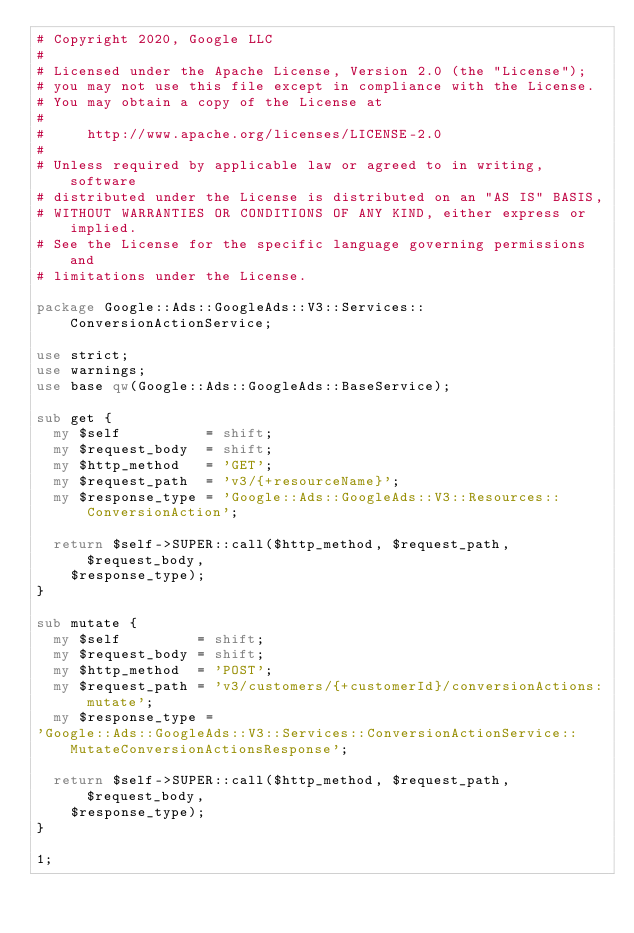Convert code to text. <code><loc_0><loc_0><loc_500><loc_500><_Perl_># Copyright 2020, Google LLC
#
# Licensed under the Apache License, Version 2.0 (the "License");
# you may not use this file except in compliance with the License.
# You may obtain a copy of the License at
#
#     http://www.apache.org/licenses/LICENSE-2.0
#
# Unless required by applicable law or agreed to in writing, software
# distributed under the License is distributed on an "AS IS" BASIS,
# WITHOUT WARRANTIES OR CONDITIONS OF ANY KIND, either express or implied.
# See the License for the specific language governing permissions and
# limitations under the License.

package Google::Ads::GoogleAds::V3::Services::ConversionActionService;

use strict;
use warnings;
use base qw(Google::Ads::GoogleAds::BaseService);

sub get {
  my $self          = shift;
  my $request_body  = shift;
  my $http_method   = 'GET';
  my $request_path  = 'v3/{+resourceName}';
  my $response_type = 'Google::Ads::GoogleAds::V3::Resources::ConversionAction';

  return $self->SUPER::call($http_method, $request_path, $request_body,
    $response_type);
}

sub mutate {
  my $self         = shift;
  my $request_body = shift;
  my $http_method  = 'POST';
  my $request_path = 'v3/customers/{+customerId}/conversionActions:mutate';
  my $response_type =
'Google::Ads::GoogleAds::V3::Services::ConversionActionService::MutateConversionActionsResponse';

  return $self->SUPER::call($http_method, $request_path, $request_body,
    $response_type);
}

1;
</code> 